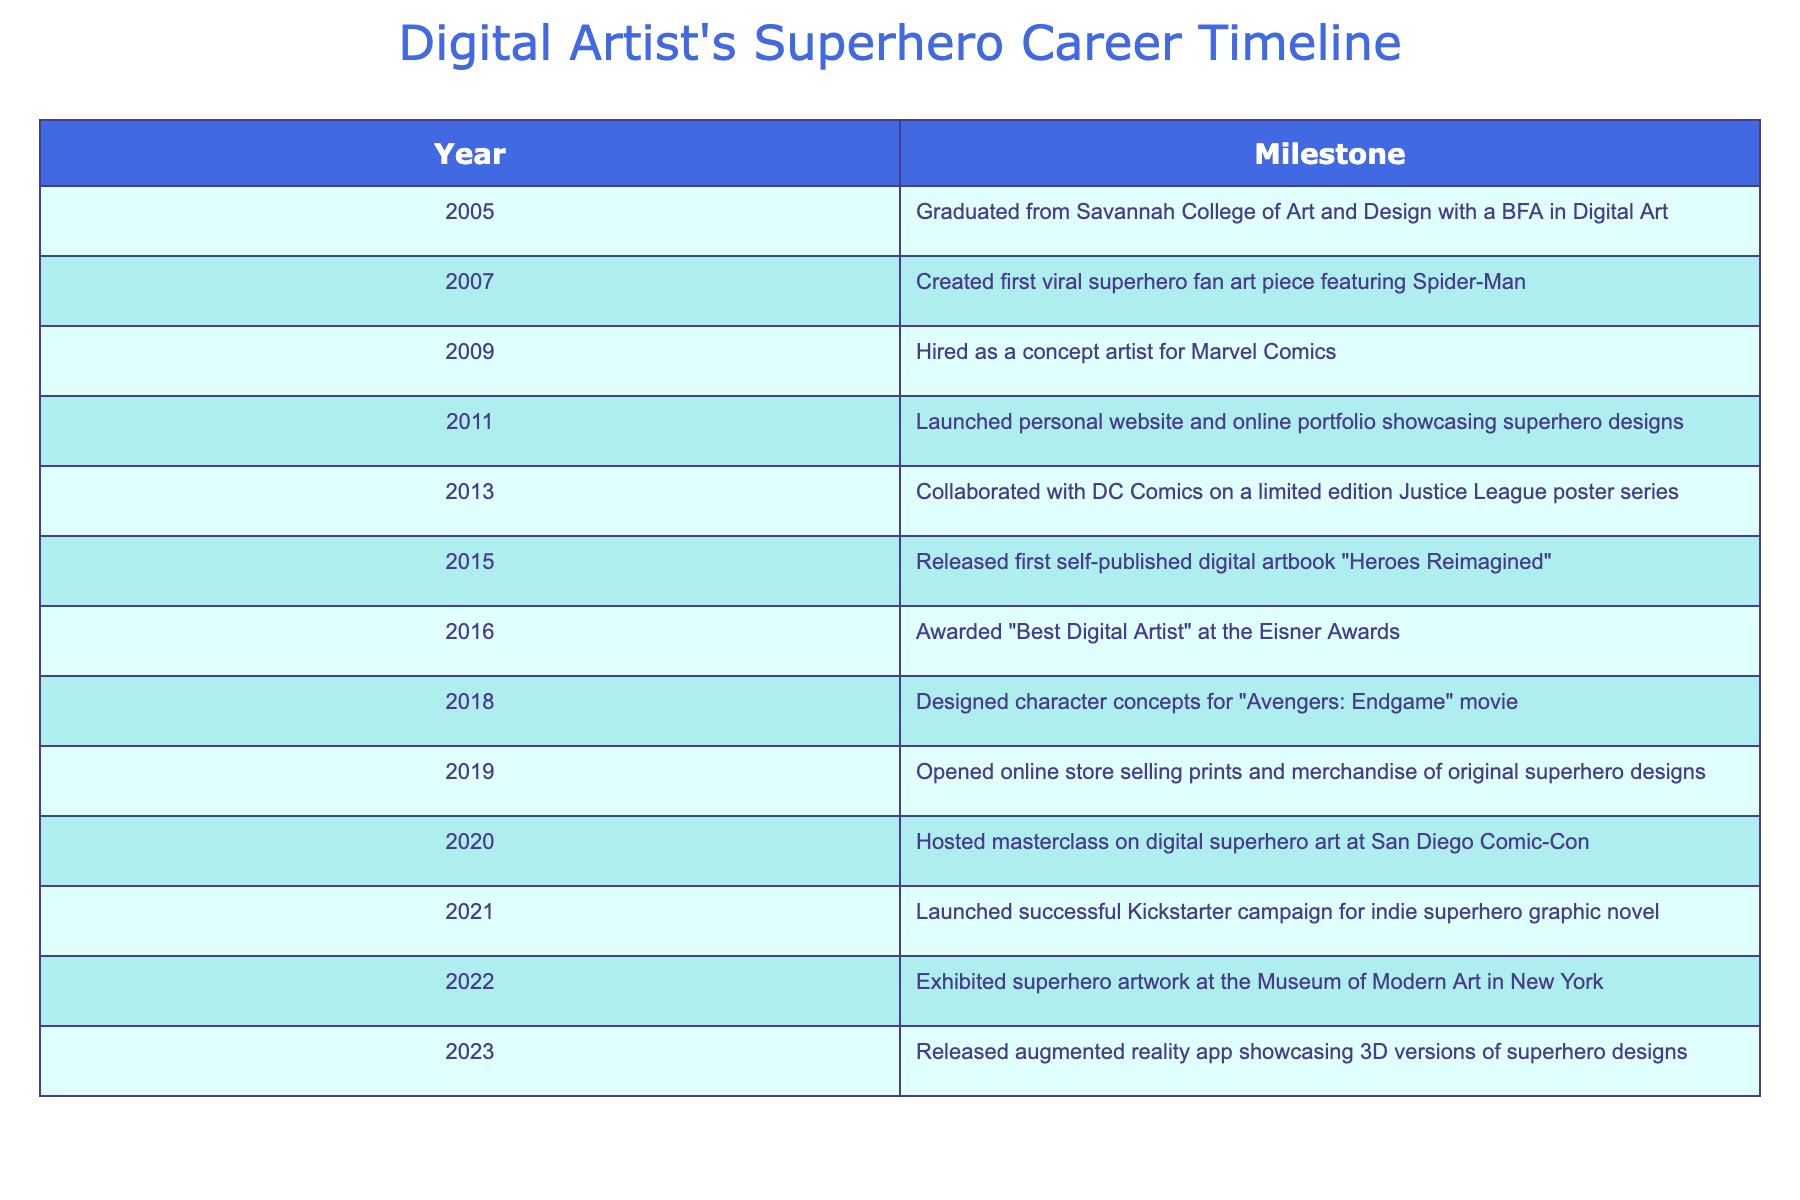What year did the artist graduate from college? According to the table, the artist graduated in 2005. This information is specifically listed under the "Year" column for the event of graduating from Savannah College of Art and Design.
Answer: 2005 What was the first significant milestone achieved by the artist? The first significant milestone noted in the table is the creation of a viral superhero fan art piece featuring Spider-Man in 2007. This is the earliest event highlighted after their graduation.
Answer: Created first viral superhero fan art piece featuring Spider-Man in 2007 How many years passed between the launch of the artist's website and the award received at the Eisner Awards? The website was launched in 2011 and the award was received in 2016. The difference in years is 2016 - 2011 = 5 years.
Answer: 5 years Did the artist ever collaborate with DC Comics? Yes, the table indicates that the artist collaborated with DC Comics in 2013 on a limited edition Justice League poster series. This confirms the collaboration.
Answer: Yes What is the total number of significant events recorded between 2005 and 2023? The table lists 13 distinct events from 2005 to 2023. Each year mentioned corresponds to a milestone, and by counting each row, we determine the total.
Answer: 13 In which year did the artist design character concepts for a movie? The artist designed character concepts for "Avengers: Endgame" in 2018, as indicated in the table under the respective year and event details.
Answer: 2018 What was the total number of award recognitions received by the artist as listed in the table? The artist won "Best Digital Artist" at the Eisner Awards in 2016, which is the only award mentioned. Therefore, the total is 1 recognition.
Answer: 1 Which milestone occurred just before the release of the artist's augmented reality app? The release of the augmented reality app in 2023 was preceded by the exhibition at the Museum of Modern Art in 2022, as listed sequentially in the timeline.
Answer: Exhibited superhero artwork at the Museum of Modern Art in 2022 How does the number of milestones between 2010 and 2015 compare to those after 2015? Between 2010 and 2015, there are 5 milestones (from 2011 to 2015), while from 2016 to 2023, there are 6 milestones (from 2016 to 2023). Since 6 is greater than 5, we find the latter period has more milestones.
Answer: More milestones after 2015 